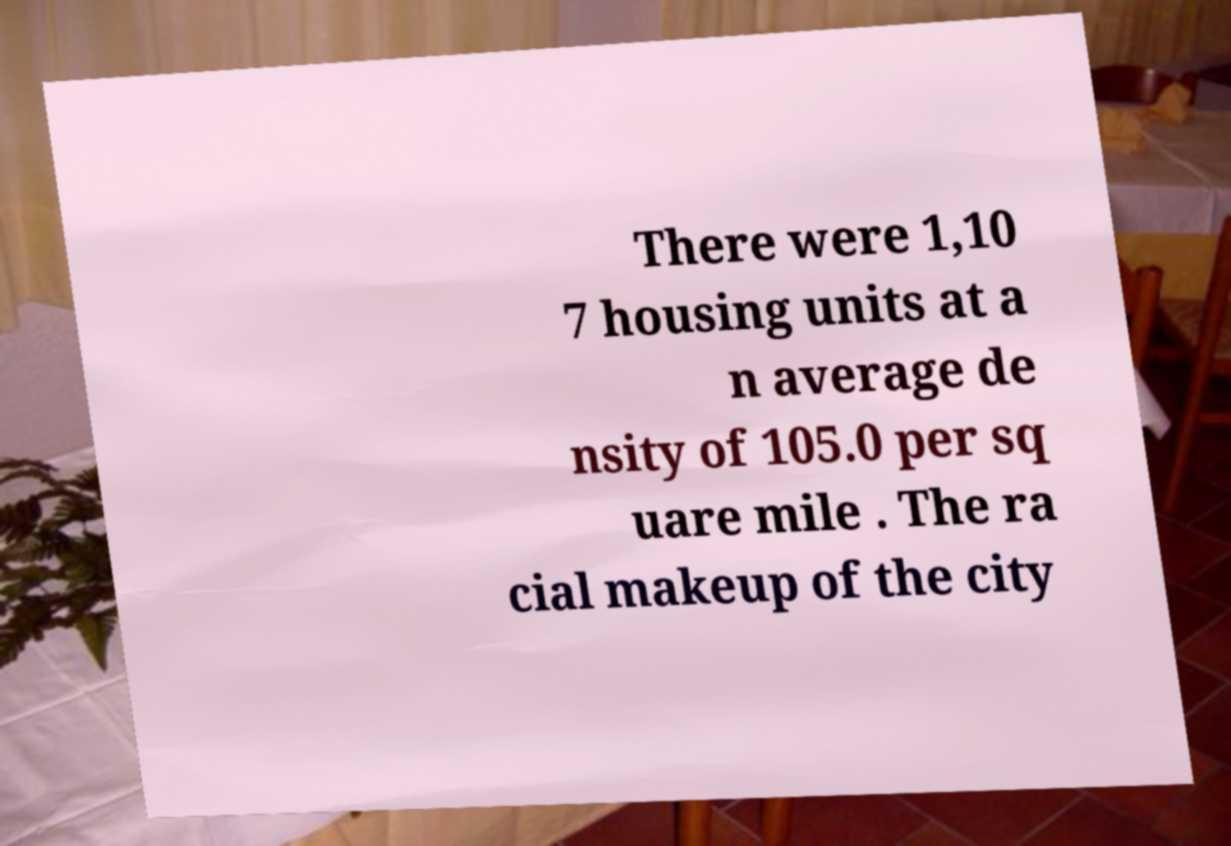There's text embedded in this image that I need extracted. Can you transcribe it verbatim? There were 1,10 7 housing units at a n average de nsity of 105.0 per sq uare mile . The ra cial makeup of the city 